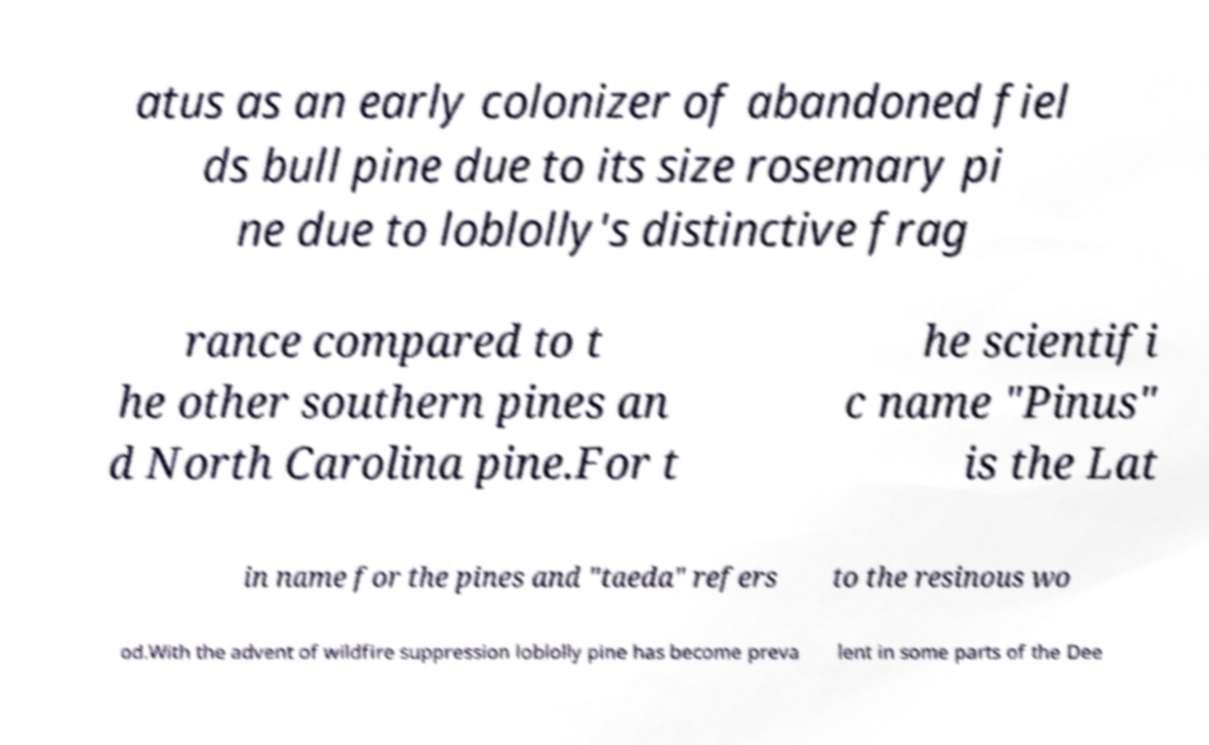What messages or text are displayed in this image? I need them in a readable, typed format. atus as an early colonizer of abandoned fiel ds bull pine due to its size rosemary pi ne due to loblolly's distinctive frag rance compared to t he other southern pines an d North Carolina pine.For t he scientifi c name "Pinus" is the Lat in name for the pines and "taeda" refers to the resinous wo od.With the advent of wildfire suppression loblolly pine has become preva lent in some parts of the Dee 